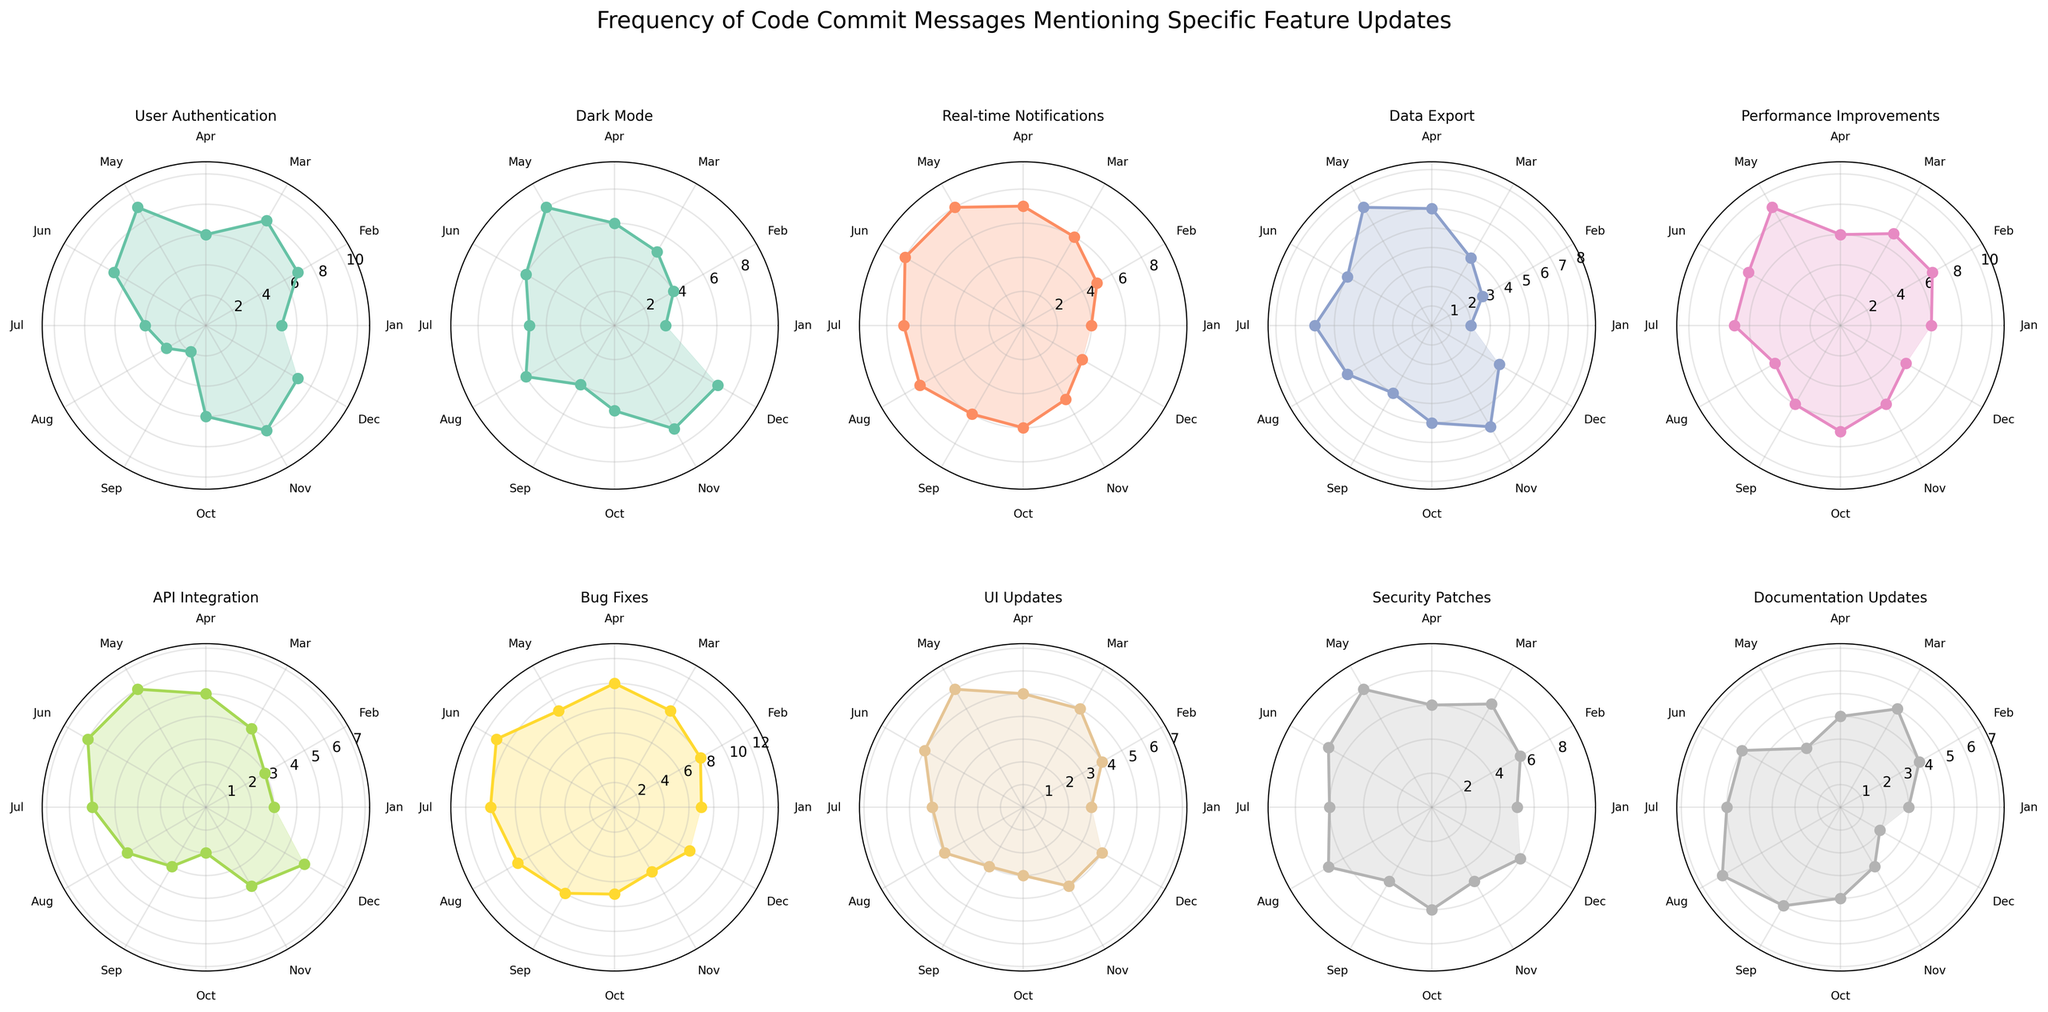Which feature has the highest frequency of code commit messages in April? Look at the subplot for April and identify the feature with the highest peak. "Bug Fixes" shows the highest point in April.
Answer: Bug Fixes Which feature shows the least variation in code commit messages throughout the year? Compare the ranges of the data points in each feature subplot. "UI Updates" has relatively consistent commit counts through the months.
Answer: UI Updates How does the frequency of commits for "Real-time Notifications" change from January to December? Trace the subplot for "Real-time Notifications" from January to December. It starts at 4 in January, peaks at 8 in May, and decreases to 4 in December.
Answer: Increases then decreases In which months does the "Performance Improvements" feature have the highest frequency? Check the "Performance Improvements" subplot for the highest peaks. Peaks are noticed in May with a frequency of 9.
Answer: May What is the combined total of commit messages for "User Authentication" and "Dark Mode" in July? Sum the commit frequencies for "User Authentication" (4) and "Dark Mode" (5) in July. 4 + 5 = 9.
Answer: 9 Which feature had a substantial drop in commit frequencies from July to August? Look at all subplots for a significant decrease from July to August. "Bug Fixes" drop from 10 to 9 is observed, but "Documentation Updates" drops from 5 to 6.
Answer: Documentation Updates Do any features have an equal number of commit messages in June? If so, which ones? Compare the commit counts listed in each subplot for June. "Dark Mode" and "Real-time Notifications" both have 6 commits.
Answer: Dark Mode, Real-time Notifications 